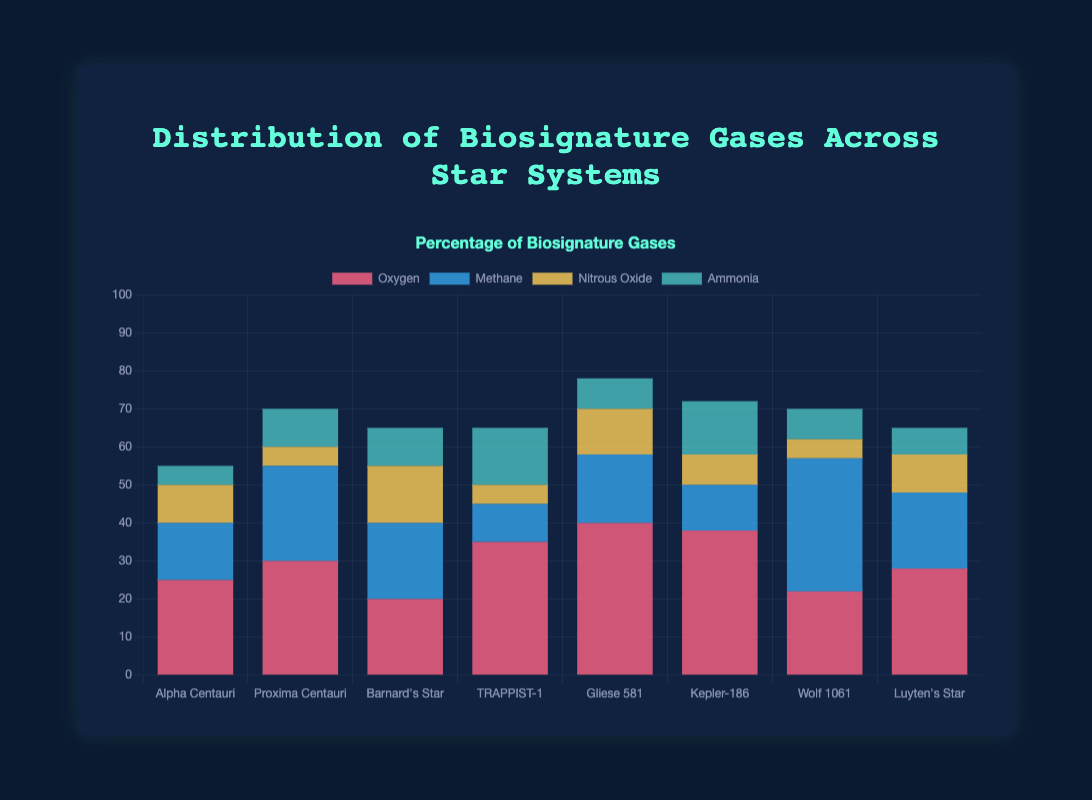Which star system has the highest total amount of biosignature gases detected? To determine which star system has the highest total amount, sum the values of all biosignature gases in each star system and compare. Gliese 581 has Oxygen (40) + Methane (18) + Nitrous Oxide (12) + Ammonia (8) = 78. No other system has a total that high.
Answer: Gliese 581 Between Oxygen and Methane, which gas has a higher total across all star systems? Sum the Oxygen values across star systems: 25 + 30 + 20 + 35 + 40 + 38 + 22 + 28 = 238. Sum the Methane values: 15 + 25 + 20 + 10 + 18 + 12 + 35 + 20 = 155. Compare these sums. Oxygen has a higher total.
Answer: Oxygen What is the average amount of Nitrous Oxide detected across all star systems? Sum the Nitrous Oxide values from each star system and then divide by the number of star systems: (10 + 5 + 15 + 5 + 12 + 8 + 5 + 10) / 8 = 70 / 8 = 8.75
Answer: 8.75 Which star system has the lowest amount of Methane detected? Compare the Methane values for each star system. TRAPPIST-1 has the lowest Methane value at 10.
Answer: TRAPPIST-1 Is there any star system where the amount of Ammonia is greater than the amount of Methane? If yes, which one? Compare Ammonia and Methane values in each star system. TRAPPIST-1 has Ammonia (15) greater than Methane (10).
Answer: TRAPPIST-1 How many star systems have an Oxygen amount greater than 30? Count the star systems where Oxygen is greater than 30: Proxima Centauri (30), TRAPPIST-1 (35), Gliese 581 (40), and Kepler-186 (38). There are 4 star systems.
Answer: 4 For Proxima Centauri, what is the difference between the amounts of Oxygen and Ammonia? Subtract the amount of Ammonia from the amount of Oxygen in Proxima Centauri: 30 - 10 = 20
Answer: 20 Which star system has the most balanced distribution of biosignature gases, meaning the smallest range (maximum - minimum) between the gases detected? Calculate the range for each star system and identify the smallest one: Alpha Centauri (25-5=20), Proxima Centauri (30-5=25), Barnard's Star (20-10=10), TRAPPIST-1 (35-5=30), Gliese 581 (40-8=32), Kepler-186 (38-8=30), Wolf 1061 (35-5=30), Luyten's Star (28-7=21). Barnard's Star has the smallest range of 10.
Answer: Barnard's Star Which gas is the least detected overall across all star systems? Sum the amounts of each gas across all star systems: Oxygen (238), Methane (155), Nitrous Oxide (70), Ammonia (77). Nitrous Oxide has the smallest total detection.
Answer: Nitrous Oxide 